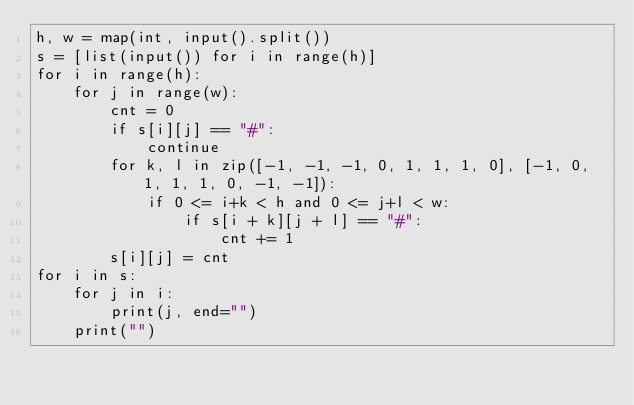Convert code to text. <code><loc_0><loc_0><loc_500><loc_500><_Python_>h, w = map(int, input().split())
s = [list(input()) for i in range(h)]
for i in range(h):
    for j in range(w):
        cnt = 0
        if s[i][j] == "#":
            continue
        for k, l in zip([-1, -1, -1, 0, 1, 1, 1, 0], [-1, 0, 1, 1, 1, 0, -1, -1]):
            if 0 <= i+k < h and 0 <= j+l < w:
                if s[i + k][j + l] == "#":
                    cnt += 1
        s[i][j] = cnt
for i in s:
    for j in i:
        print(j, end="")
    print("")</code> 